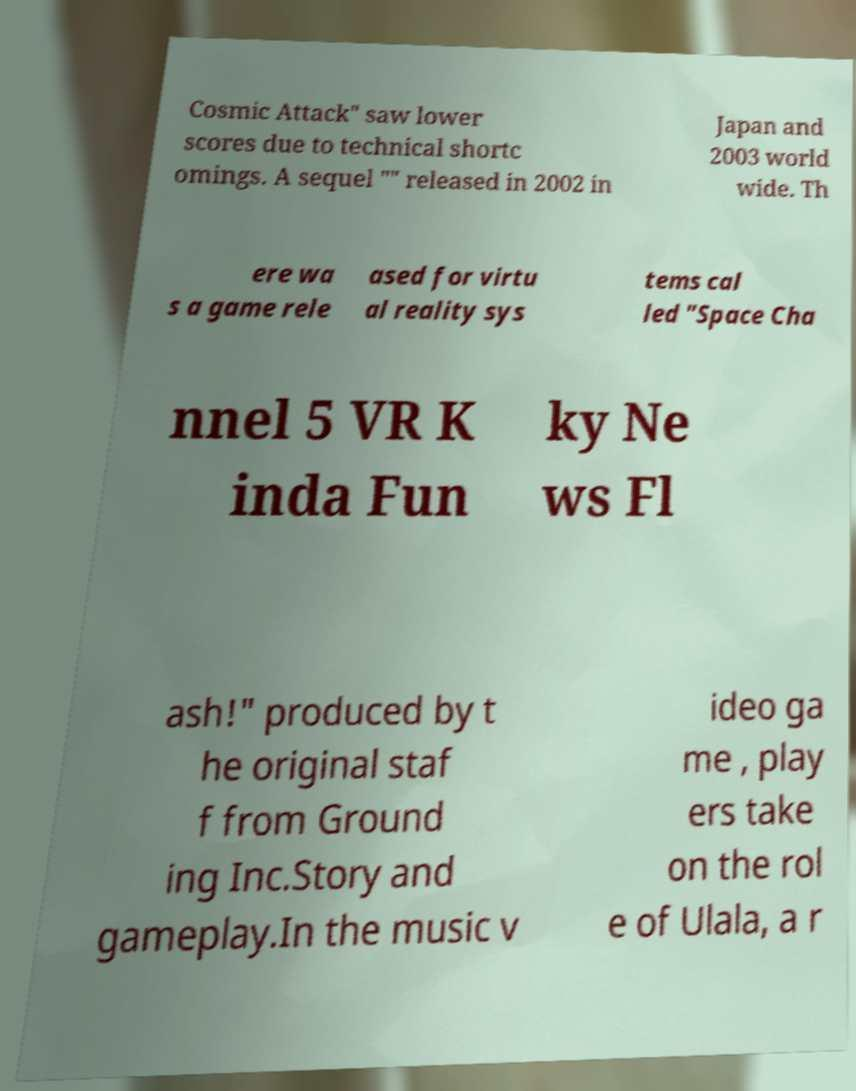Can you accurately transcribe the text from the provided image for me? Cosmic Attack" saw lower scores due to technical shortc omings. A sequel "" released in 2002 in Japan and 2003 world wide. Th ere wa s a game rele ased for virtu al reality sys tems cal led "Space Cha nnel 5 VR K inda Fun ky Ne ws Fl ash!" produced by t he original staf f from Ground ing Inc.Story and gameplay.In the music v ideo ga me , play ers take on the rol e of Ulala, a r 